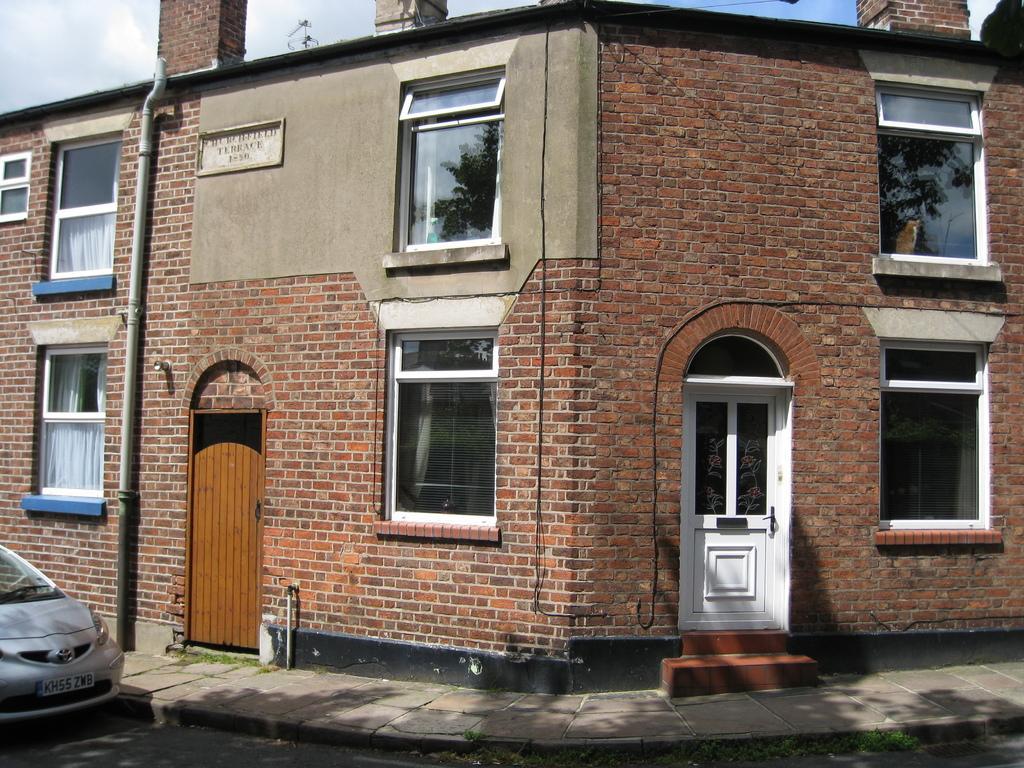Please provide a concise description of this image. In this image we can see a building, doors, windows, board, pipe, road, and a vehicle which is truncated. At the top of the image we can see sky with clouds. 